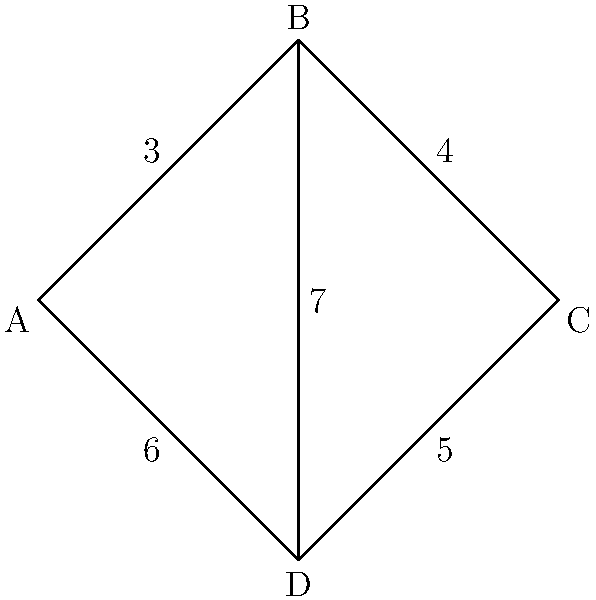In the given network topology diagram, nodes represent servers in a distributed messaging system, and edges represent communication links with their associated latencies (in milliseconds). What is the shortest path and its total latency from node A to node C? To find the shortest path from node A to node C, we need to consider all possible paths and their total latencies:

1. Path A-B-C:
   Latency = 3 + 4 = 7 ms

2. Path A-D-C:
   Latency = 6 + 5 = 11 ms

3. Path A-D-B-C:
   Latency = 6 + 7 + 4 = 17 ms

4. Path A-B-D-C:
   Latency = 3 + 7 + 5 = 15 ms

The shortest path is A-B-C with a total latency of 7 ms.

This problem is related to distributed systems and messaging systems like RocketMQ because it simulates finding the optimal route for message delivery in a network of servers. In real-world scenarios, such optimization is crucial for minimizing message latency and improving overall system performance.
Answer: A-B-C, 7 ms 